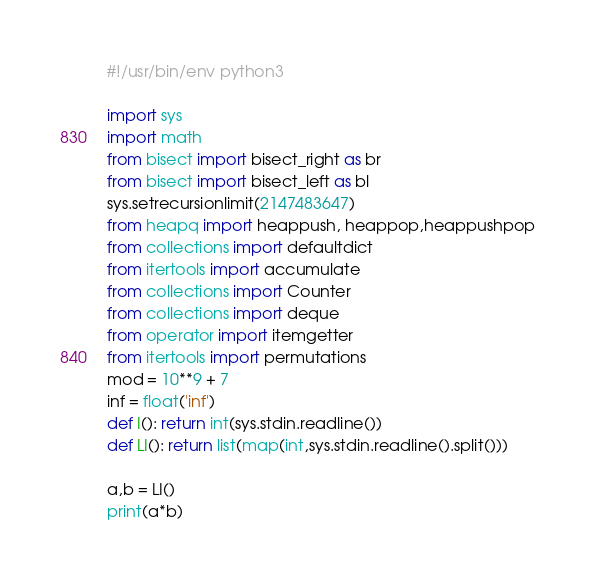Convert code to text. <code><loc_0><loc_0><loc_500><loc_500><_Python_>#!/usr/bin/env python3

import sys
import math
from bisect import bisect_right as br
from bisect import bisect_left as bl
sys.setrecursionlimit(2147483647)
from heapq import heappush, heappop,heappushpop
from collections import defaultdict
from itertools import accumulate
from collections import Counter
from collections import deque
from operator import itemgetter
from itertools import permutations
mod = 10**9 + 7
inf = float('inf')
def I(): return int(sys.stdin.readline())
def LI(): return list(map(int,sys.stdin.readline().split()))

a,b = LI()
print(a*b)</code> 